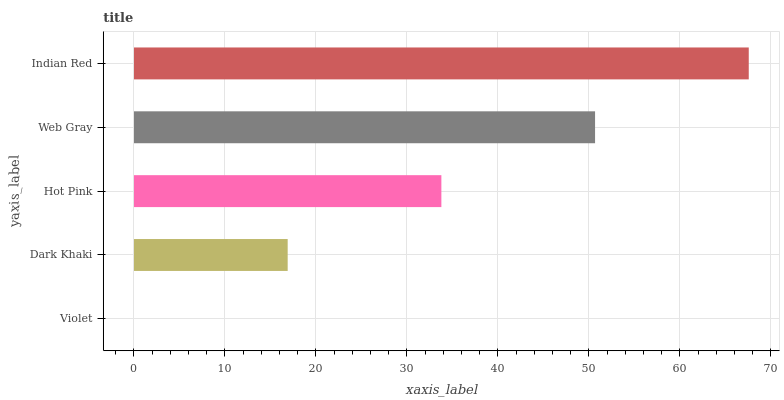Is Violet the minimum?
Answer yes or no. Yes. Is Indian Red the maximum?
Answer yes or no. Yes. Is Dark Khaki the minimum?
Answer yes or no. No. Is Dark Khaki the maximum?
Answer yes or no. No. Is Dark Khaki greater than Violet?
Answer yes or no. Yes. Is Violet less than Dark Khaki?
Answer yes or no. Yes. Is Violet greater than Dark Khaki?
Answer yes or no. No. Is Dark Khaki less than Violet?
Answer yes or no. No. Is Hot Pink the high median?
Answer yes or no. Yes. Is Hot Pink the low median?
Answer yes or no. Yes. Is Web Gray the high median?
Answer yes or no. No. Is Web Gray the low median?
Answer yes or no. No. 